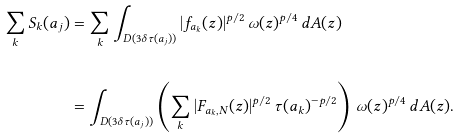<formula> <loc_0><loc_0><loc_500><loc_500>\sum _ { k } S _ { k } ( a _ { j } ) & = \sum _ { k } \int _ { D ( 3 \delta \tau ( a _ { j } ) ) } | f _ { a _ { k } } ( z ) | ^ { p / 2 } \, \omega ( z ) ^ { p / 4 } \, d A ( z ) \\ \\ & = \int _ { D ( 3 \delta \tau ( a _ { j } ) ) } \left ( \sum _ { k } | F _ { a _ { k } , N } ( z ) | ^ { p / 2 } \, \tau ( a _ { k } ) ^ { - p / 2 } \right ) \, \omega ( z ) ^ { p / 4 } \, d A ( z ) .</formula> 